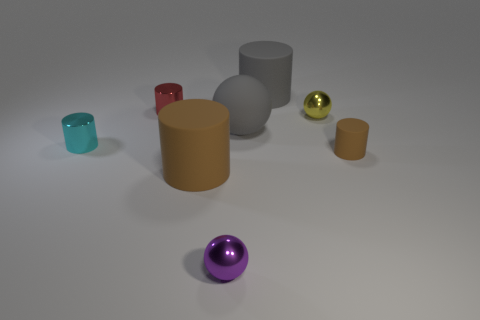Subtract all small purple shiny spheres. How many spheres are left? 2 Add 1 big cyan metallic cubes. How many objects exist? 9 Subtract all red cylinders. How many cylinders are left? 4 Subtract all spheres. How many objects are left? 5 Subtract 5 cylinders. How many cylinders are left? 0 Subtract all green metallic cubes. Subtract all big gray matte objects. How many objects are left? 6 Add 6 purple shiny things. How many purple shiny things are left? 7 Add 8 big gray rubber balls. How many big gray rubber balls exist? 9 Subtract 1 cyan cylinders. How many objects are left? 7 Subtract all cyan balls. Subtract all gray cubes. How many balls are left? 3 